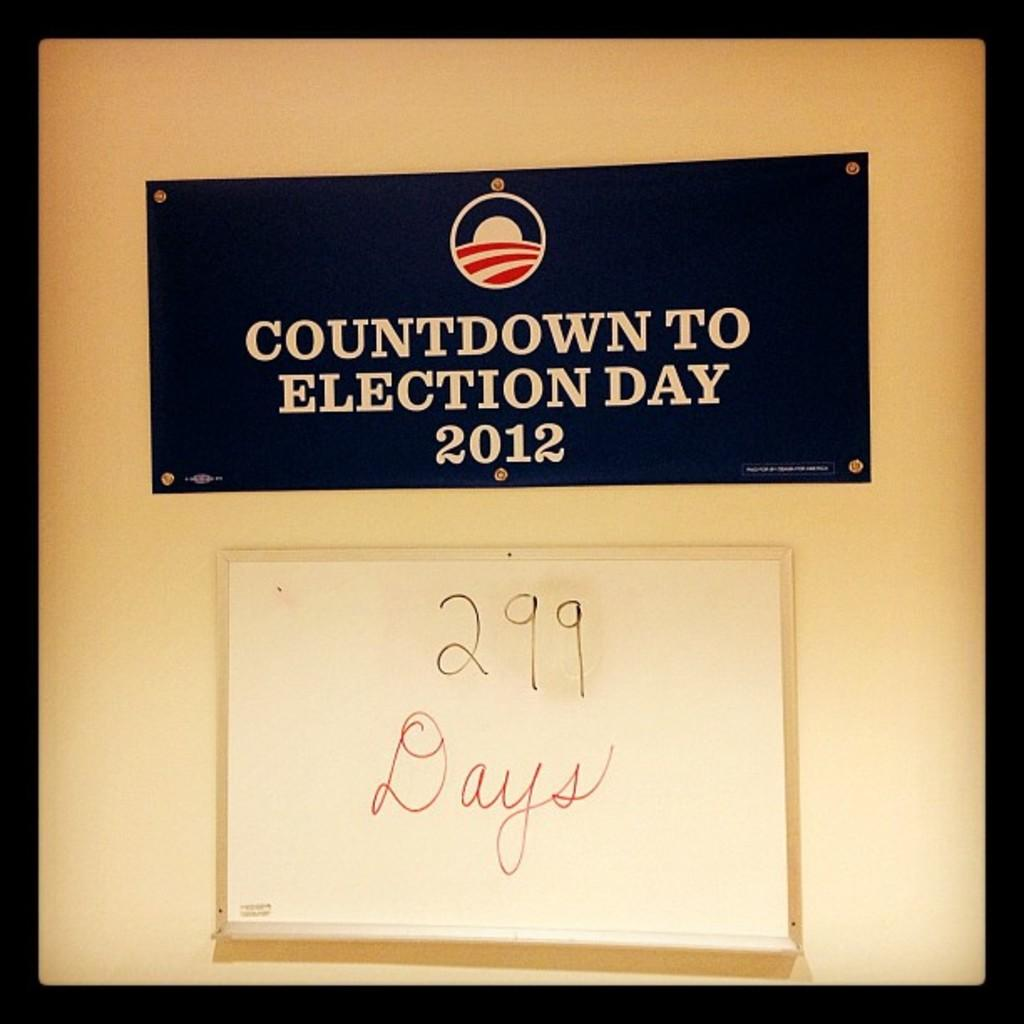What is the main subject in the center of the image? There is a banner in the center of the image. What message does the banner convey? The banner has the text "Countdown To Election Day 2012". What color is used as a border around the image? There is a black color border around the image. How many wheels can be seen on the banner in the image? There are no wheels present on the banner or in the image. What type of pain is being experienced by the banner in the image? The banner is an inanimate object and cannot experience pain. 